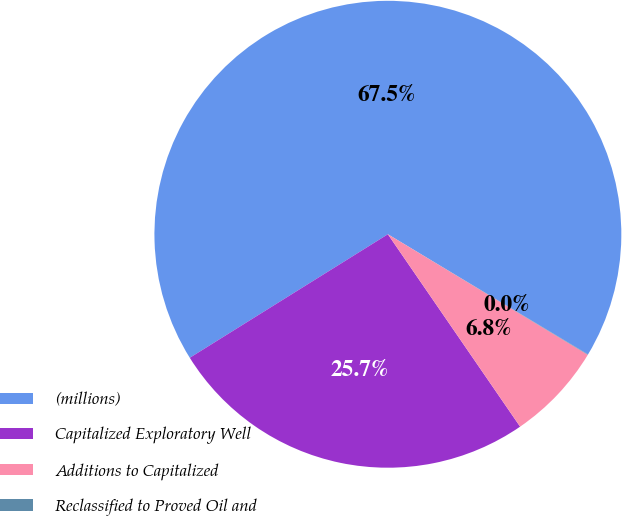<chart> <loc_0><loc_0><loc_500><loc_500><pie_chart><fcel>(millions)<fcel>Capitalized Exploratory Well<fcel>Additions to Capitalized<fcel>Reclassified to Proved Oil and<nl><fcel>67.48%<fcel>25.71%<fcel>6.78%<fcel>0.03%<nl></chart> 